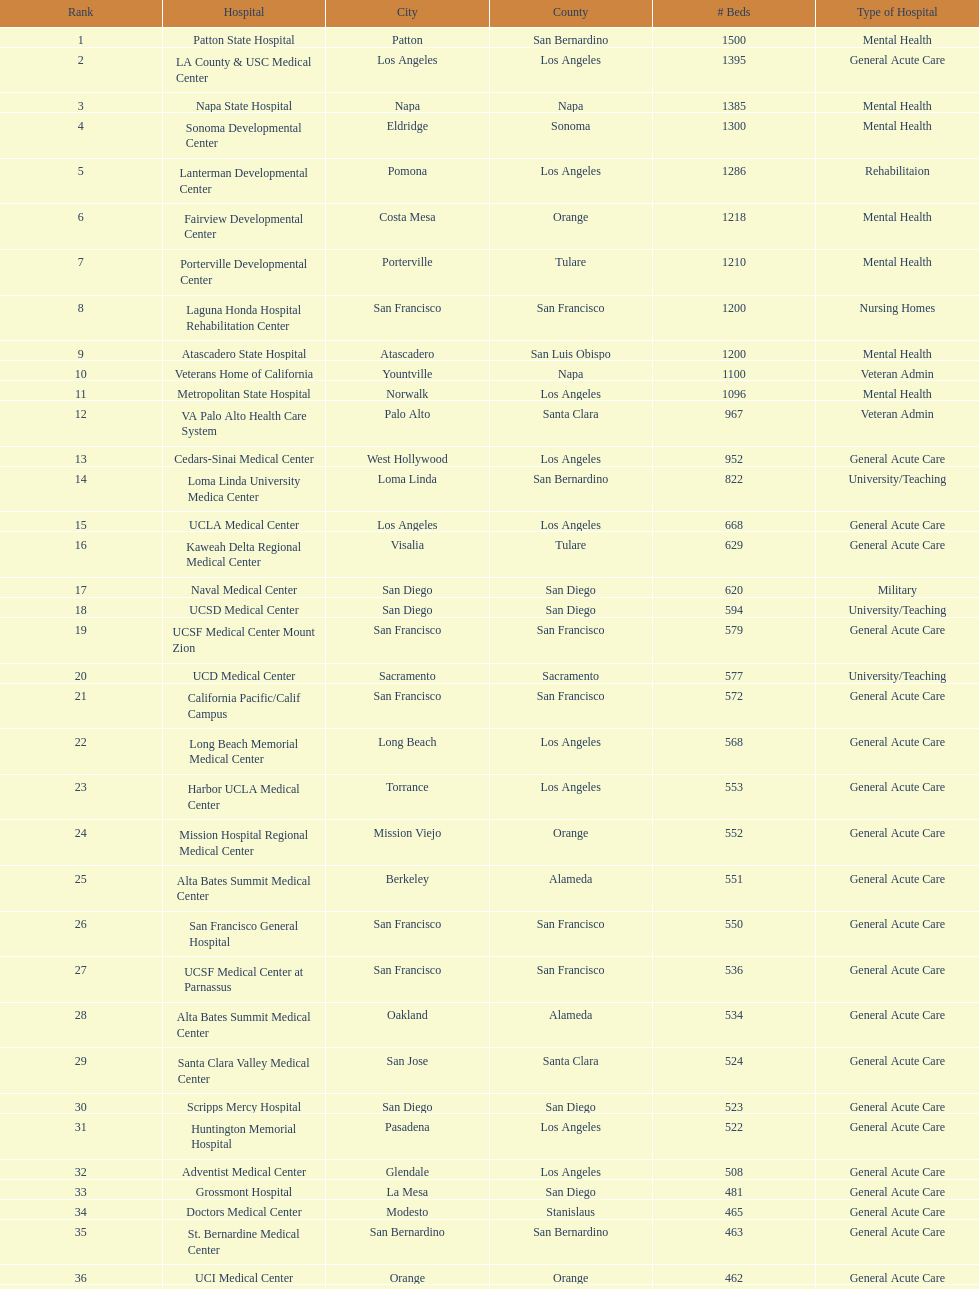Which category of hospitals can be compared to grossmont hospital? General Acute Care. 